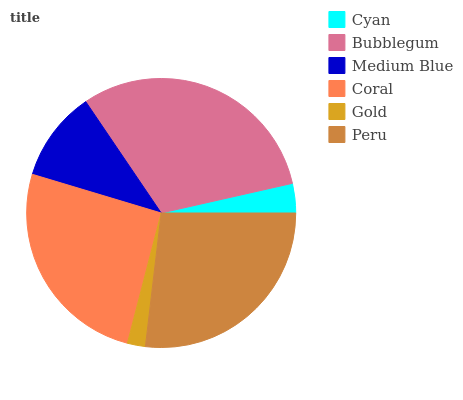Is Gold the minimum?
Answer yes or no. Yes. Is Bubblegum the maximum?
Answer yes or no. Yes. Is Medium Blue the minimum?
Answer yes or no. No. Is Medium Blue the maximum?
Answer yes or no. No. Is Bubblegum greater than Medium Blue?
Answer yes or no. Yes. Is Medium Blue less than Bubblegum?
Answer yes or no. Yes. Is Medium Blue greater than Bubblegum?
Answer yes or no. No. Is Bubblegum less than Medium Blue?
Answer yes or no. No. Is Coral the high median?
Answer yes or no. Yes. Is Medium Blue the low median?
Answer yes or no. Yes. Is Gold the high median?
Answer yes or no. No. Is Bubblegum the low median?
Answer yes or no. No. 